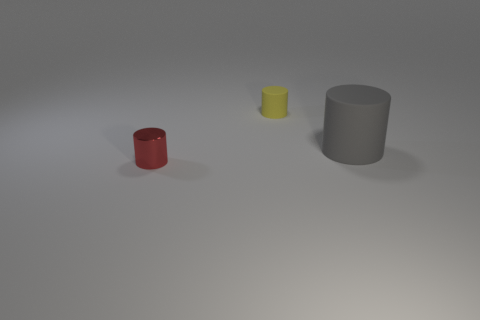What is the size comparison between the cylinders and the color variety they represent? The image showcases a small red cylinder, a yellow cylinder slightly shorter in height, and a larger grey cylinder. This displays a range of sizes and a palette of red, yellow, and grey for these objects. 